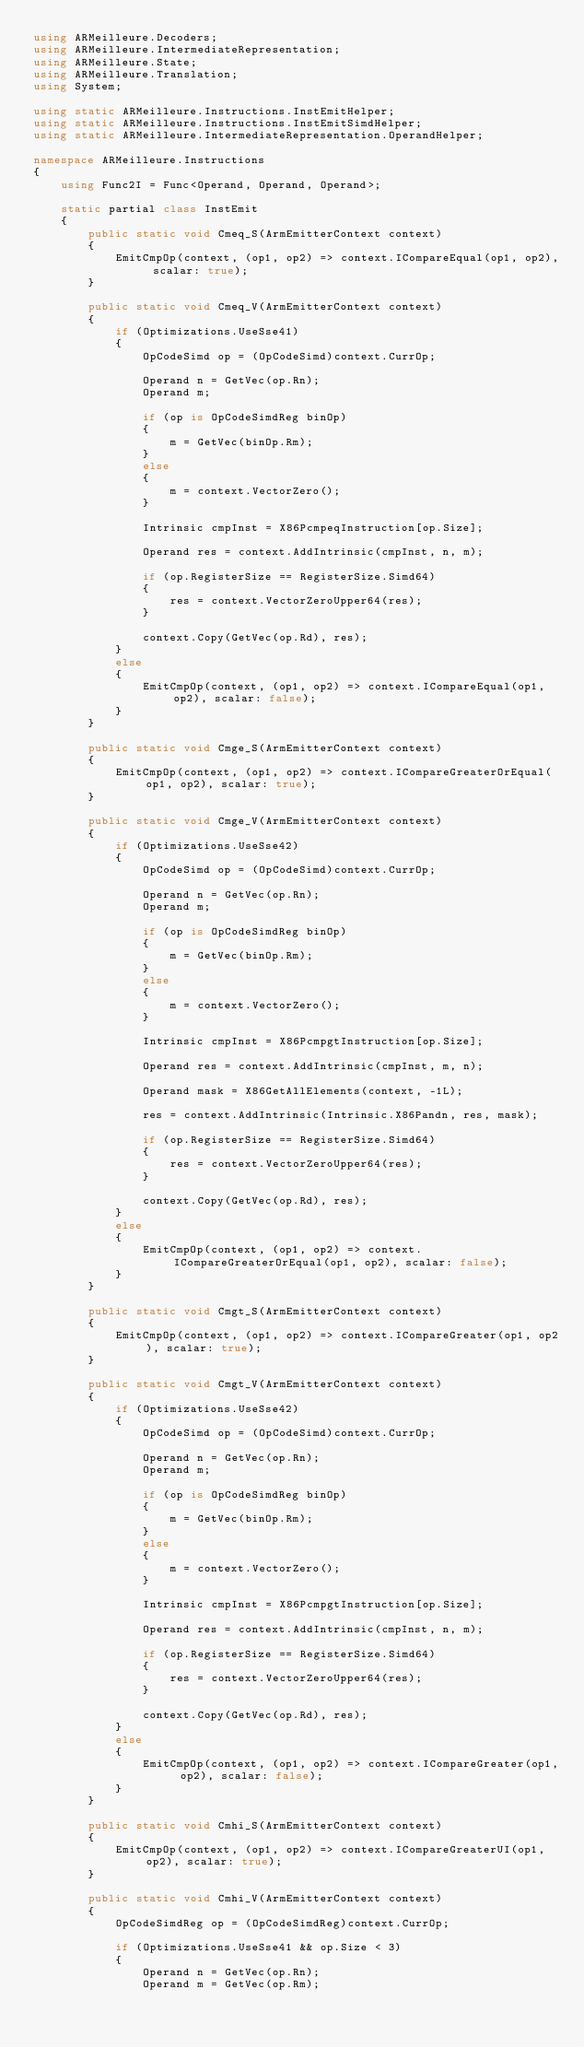<code> <loc_0><loc_0><loc_500><loc_500><_C#_>using ARMeilleure.Decoders;
using ARMeilleure.IntermediateRepresentation;
using ARMeilleure.State;
using ARMeilleure.Translation;
using System;

using static ARMeilleure.Instructions.InstEmitHelper;
using static ARMeilleure.Instructions.InstEmitSimdHelper;
using static ARMeilleure.IntermediateRepresentation.OperandHelper;

namespace ARMeilleure.Instructions
{
    using Func2I = Func<Operand, Operand, Operand>;

    static partial class InstEmit
    {
        public static void Cmeq_S(ArmEmitterContext context)
        {
            EmitCmpOp(context, (op1, op2) => context.ICompareEqual(op1, op2), scalar: true);
        }

        public static void Cmeq_V(ArmEmitterContext context)
        {
            if (Optimizations.UseSse41)
            {
                OpCodeSimd op = (OpCodeSimd)context.CurrOp;

                Operand n = GetVec(op.Rn);
                Operand m;

                if (op is OpCodeSimdReg binOp)
                {
                    m = GetVec(binOp.Rm);
                }
                else
                {
                    m = context.VectorZero();
                }

                Intrinsic cmpInst = X86PcmpeqInstruction[op.Size];

                Operand res = context.AddIntrinsic(cmpInst, n, m);

                if (op.RegisterSize == RegisterSize.Simd64)
                {
                    res = context.VectorZeroUpper64(res);
                }

                context.Copy(GetVec(op.Rd), res);
            }
            else
            {
                EmitCmpOp(context, (op1, op2) => context.ICompareEqual(op1, op2), scalar: false);
            }
        }

        public static void Cmge_S(ArmEmitterContext context)
        {
            EmitCmpOp(context, (op1, op2) => context.ICompareGreaterOrEqual(op1, op2), scalar: true);
        }

        public static void Cmge_V(ArmEmitterContext context)
        {
            if (Optimizations.UseSse42)
            {
                OpCodeSimd op = (OpCodeSimd)context.CurrOp;

                Operand n = GetVec(op.Rn);
                Operand m;

                if (op is OpCodeSimdReg binOp)
                {
                    m = GetVec(binOp.Rm);
                }
                else
                {
                    m = context.VectorZero();
                }

                Intrinsic cmpInst = X86PcmpgtInstruction[op.Size];

                Operand res = context.AddIntrinsic(cmpInst, m, n);

                Operand mask = X86GetAllElements(context, -1L);

                res = context.AddIntrinsic(Intrinsic.X86Pandn, res, mask);

                if (op.RegisterSize == RegisterSize.Simd64)
                {
                    res = context.VectorZeroUpper64(res);
                }

                context.Copy(GetVec(op.Rd), res);
            }
            else
            {
                EmitCmpOp(context, (op1, op2) => context.ICompareGreaterOrEqual(op1, op2), scalar: false);
            }
        }

        public static void Cmgt_S(ArmEmitterContext context)
        {
            EmitCmpOp(context, (op1, op2) => context.ICompareGreater(op1, op2), scalar: true);
        }

        public static void Cmgt_V(ArmEmitterContext context)
        {
            if (Optimizations.UseSse42)
            {
                OpCodeSimd op = (OpCodeSimd)context.CurrOp;

                Operand n = GetVec(op.Rn);
                Operand m;

                if (op is OpCodeSimdReg binOp)
                {
                    m = GetVec(binOp.Rm);
                }
                else
                {
                    m = context.VectorZero();
                }

                Intrinsic cmpInst = X86PcmpgtInstruction[op.Size];

                Operand res = context.AddIntrinsic(cmpInst, n, m);

                if (op.RegisterSize == RegisterSize.Simd64)
                {
                    res = context.VectorZeroUpper64(res);
                }

                context.Copy(GetVec(op.Rd), res);
            }
            else
            {
                EmitCmpOp(context, (op1, op2) => context.ICompareGreater(op1, op2), scalar: false);
            }
        }

        public static void Cmhi_S(ArmEmitterContext context)
        {
            EmitCmpOp(context, (op1, op2) => context.ICompareGreaterUI(op1, op2), scalar: true);
        }

        public static void Cmhi_V(ArmEmitterContext context)
        {
            OpCodeSimdReg op = (OpCodeSimdReg)context.CurrOp;

            if (Optimizations.UseSse41 && op.Size < 3)
            {
                Operand n = GetVec(op.Rn);
                Operand m = GetVec(op.Rm);
</code> 